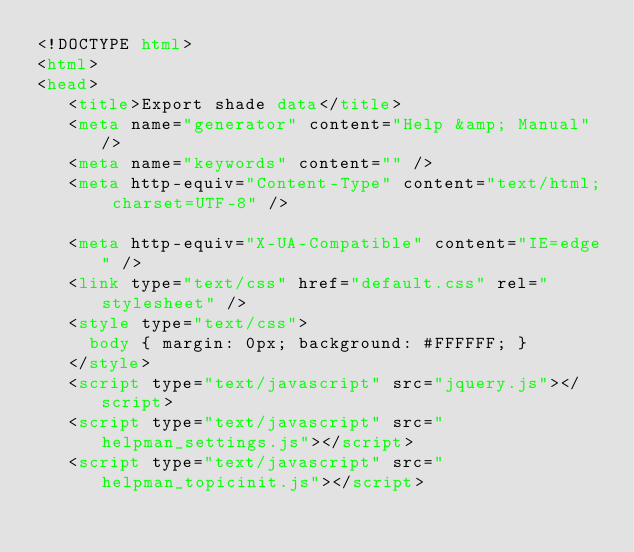<code> <loc_0><loc_0><loc_500><loc_500><_HTML_><!DOCTYPE html>
<html>
<head>
   <title>Export shade data</title>
   <meta name="generator" content="Help &amp; Manual" />
   <meta name="keywords" content="" />
   <meta http-equiv="Content-Type" content="text/html; charset=UTF-8" />
   
   <meta http-equiv="X-UA-Compatible" content="IE=edge" />
   <link type="text/css" href="default.css" rel="stylesheet" />
   <style type="text/css">
     body { margin: 0px; background: #FFFFFF; }
   </style>
   <script type="text/javascript" src="jquery.js"></script>
   <script type="text/javascript" src="helpman_settings.js"></script>
   <script type="text/javascript" src="helpman_topicinit.js"></script>
</code> 